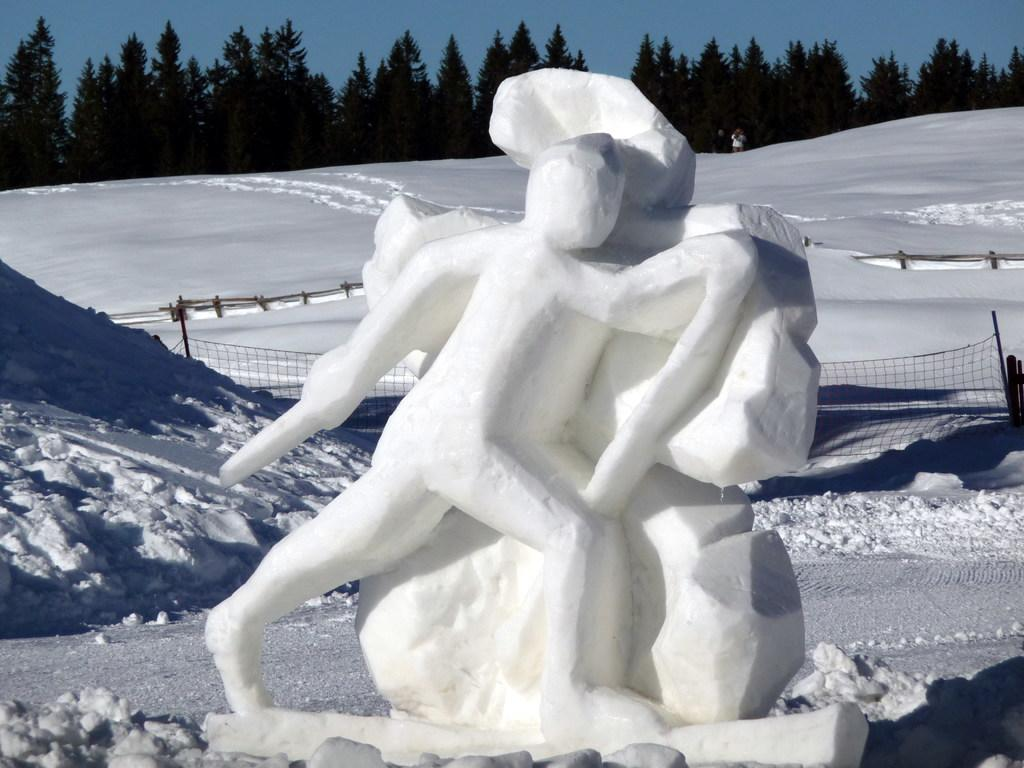What is the main subject of the image? There is a snow sculpture in the image. What can be seen in the background of the image? There is snow, a net, trees, and the sky visible in the background of the image. What type of cabbage is being used to make a statement in the image? There is no cabbage present in the image, and no statement is being made with cabbage. 